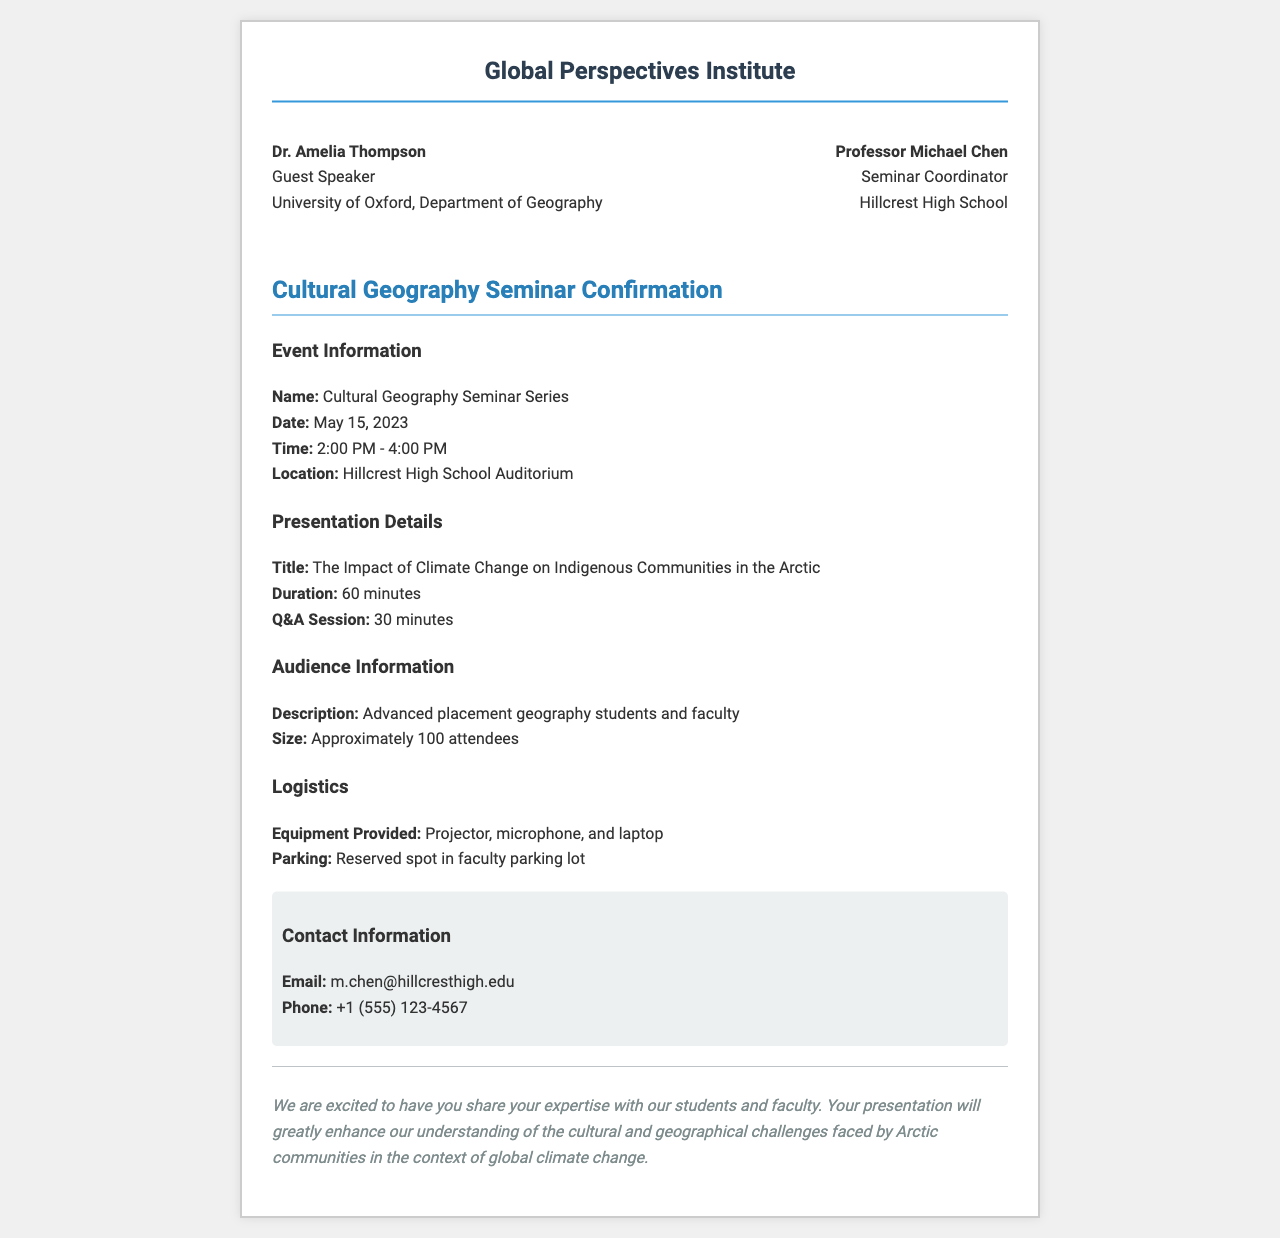What is the name of the seminar? The name of the seminar is specified in the document as "Cultural Geography Seminar Series."
Answer: Cultural Geography Seminar Series Who is the guest speaker? The document names the guest speaker as "Dr. Amelia Thompson."
Answer: Dr. Amelia Thompson What is the date of the seminar? The date of the seminar is given in the document as "May 15, 2023."
Answer: May 15, 2023 How long is the presentation? The duration of the presentation is stated as "60 minutes."
Answer: 60 minutes What is the title of the presentation? The title of the presentation is detailed in the document as "The Impact of Climate Change on Indigenous Communities in the Arctic."
Answer: The Impact of Climate Change on Indigenous Communities in the Arctic What is the expected audience size? The document specifies the audience size as "Approximately 100 attendees."
Answer: Approximately 100 attendees What equipment will be provided? The document lists the equipment provided, including "Projector, microphone, and laptop."
Answer: Projector, microphone, and laptop Who is the seminar coordinator? The document identifies the seminar coordinator as "Professor Michael Chen."
Answer: Professor Michael Chen What is the Q&A session duration? The duration of the Q&A session is mentioned as "30 minutes."
Answer: 30 minutes 